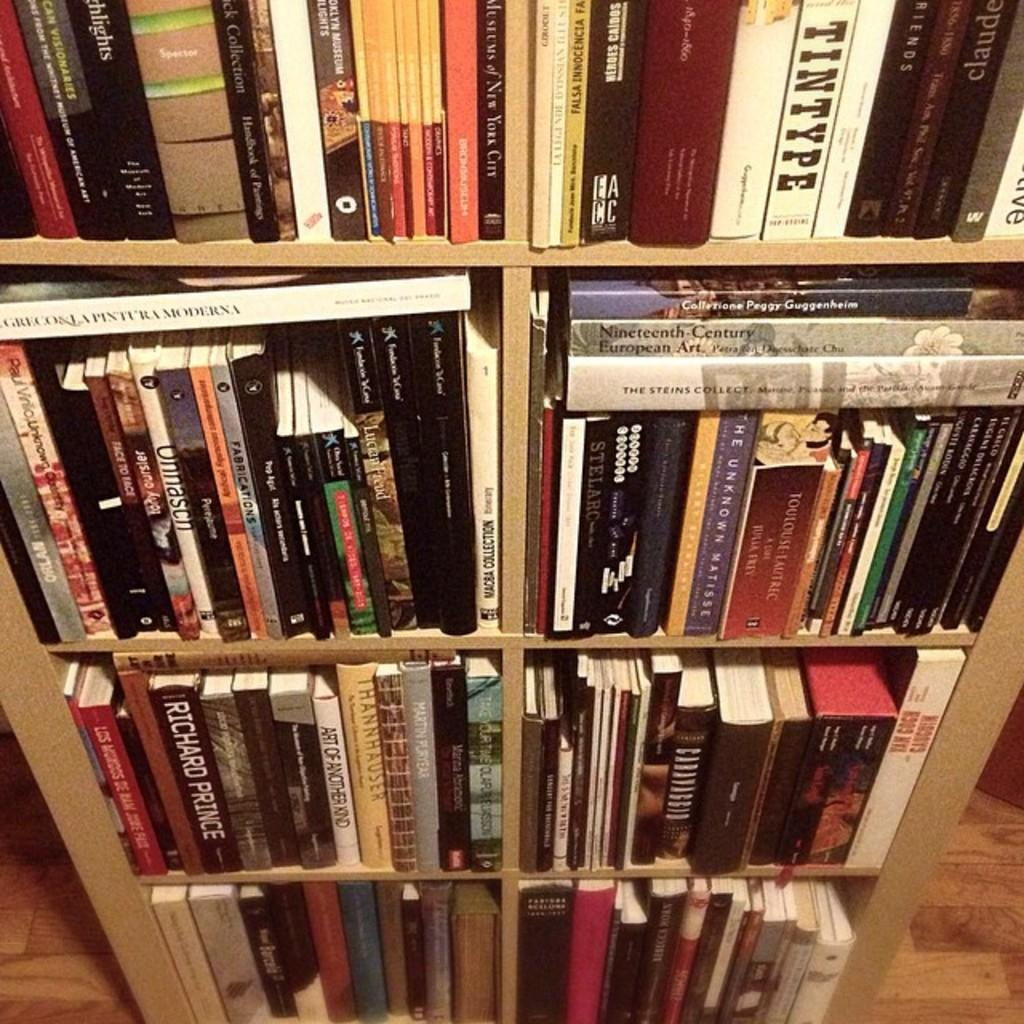Provide a one-sentence caption for the provided image. A shelf unit full of books, including Art Of Another Kind on the second shelf. 